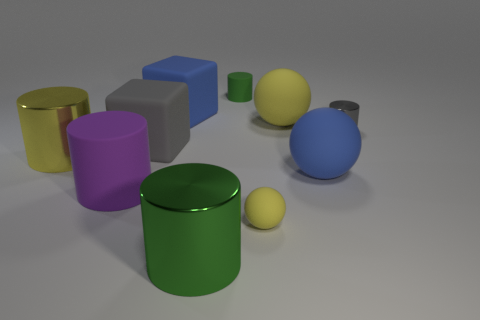Subtract all purple cylinders. How many cylinders are left? 4 Subtract 1 cylinders. How many cylinders are left? 4 Subtract all green rubber cylinders. How many cylinders are left? 4 Subtract all brown cylinders. Subtract all cyan balls. How many cylinders are left? 5 Subtract all cubes. How many objects are left? 8 Subtract all small yellow matte balls. Subtract all small green objects. How many objects are left? 8 Add 8 tiny green objects. How many tiny green objects are left? 9 Add 3 small yellow objects. How many small yellow objects exist? 4 Subtract 0 brown spheres. How many objects are left? 10 